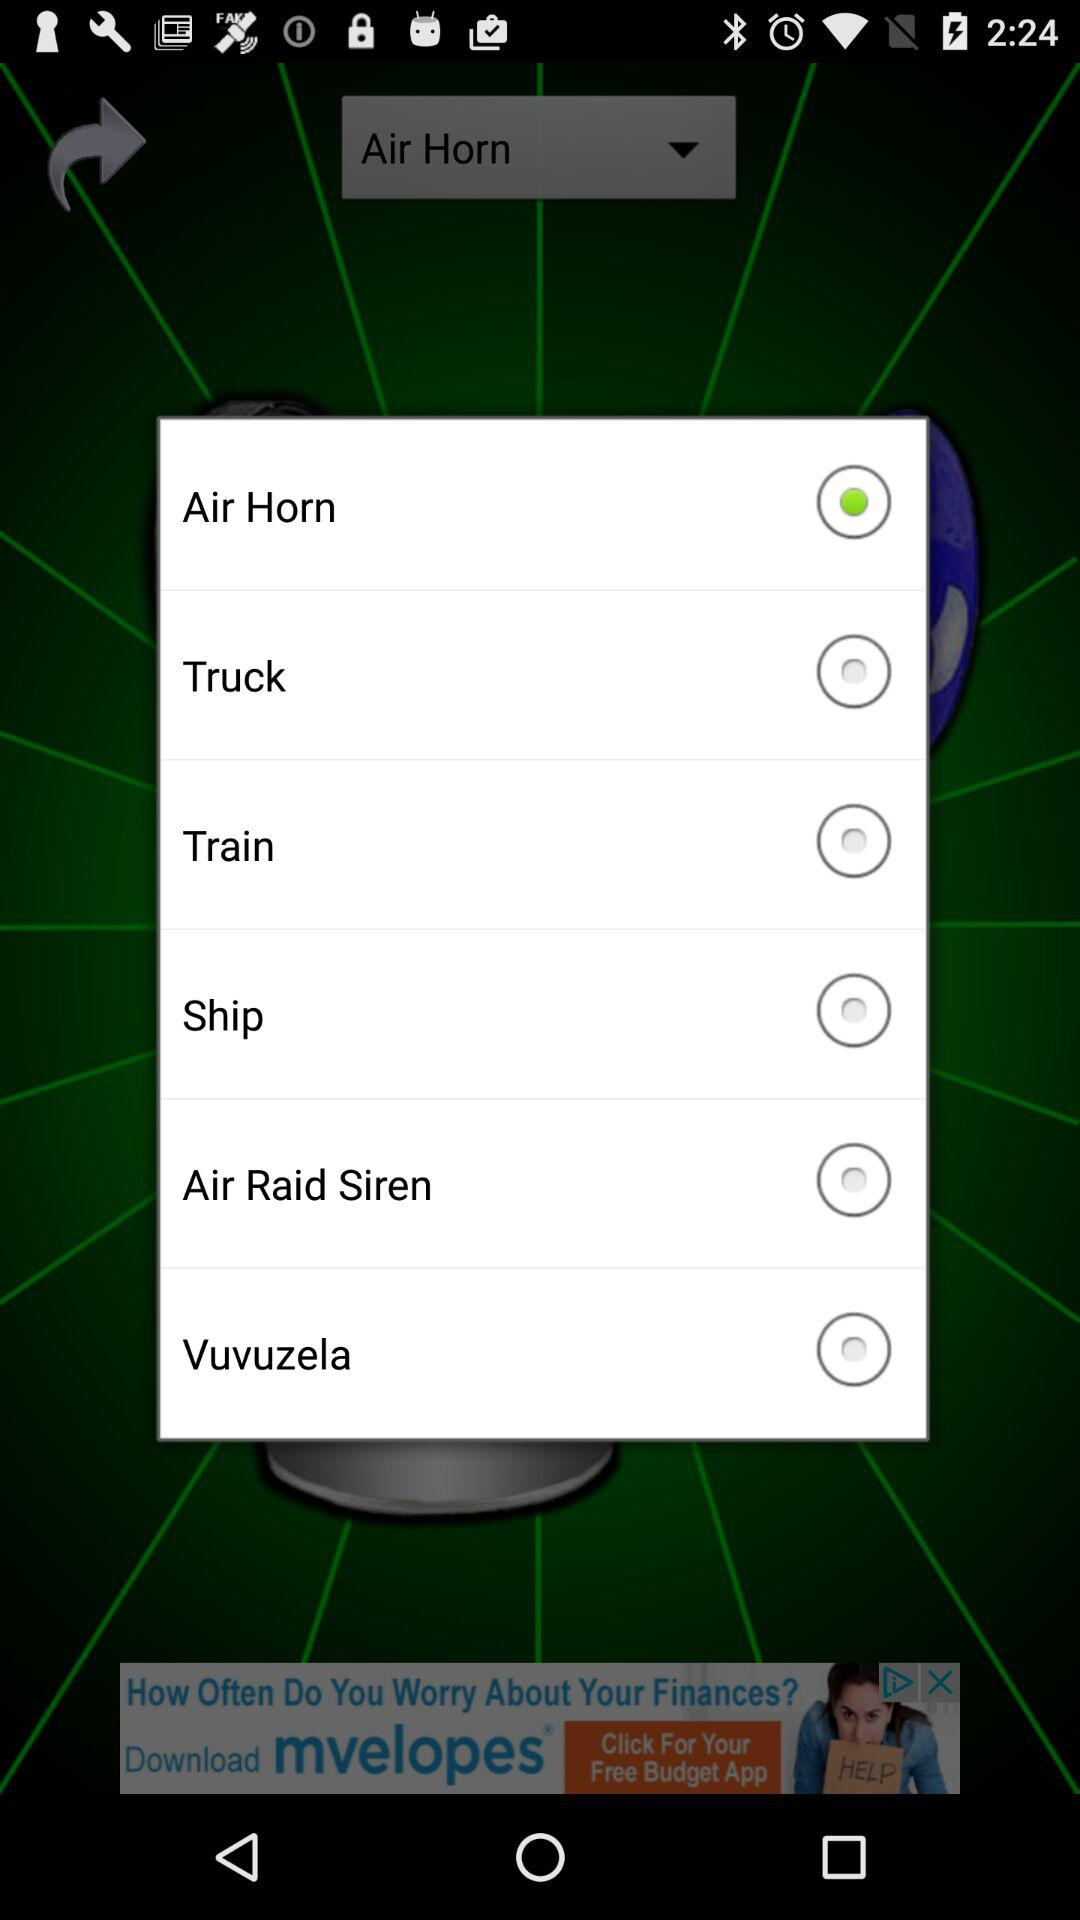What is the selected option? The selected option is "Air Horn". 